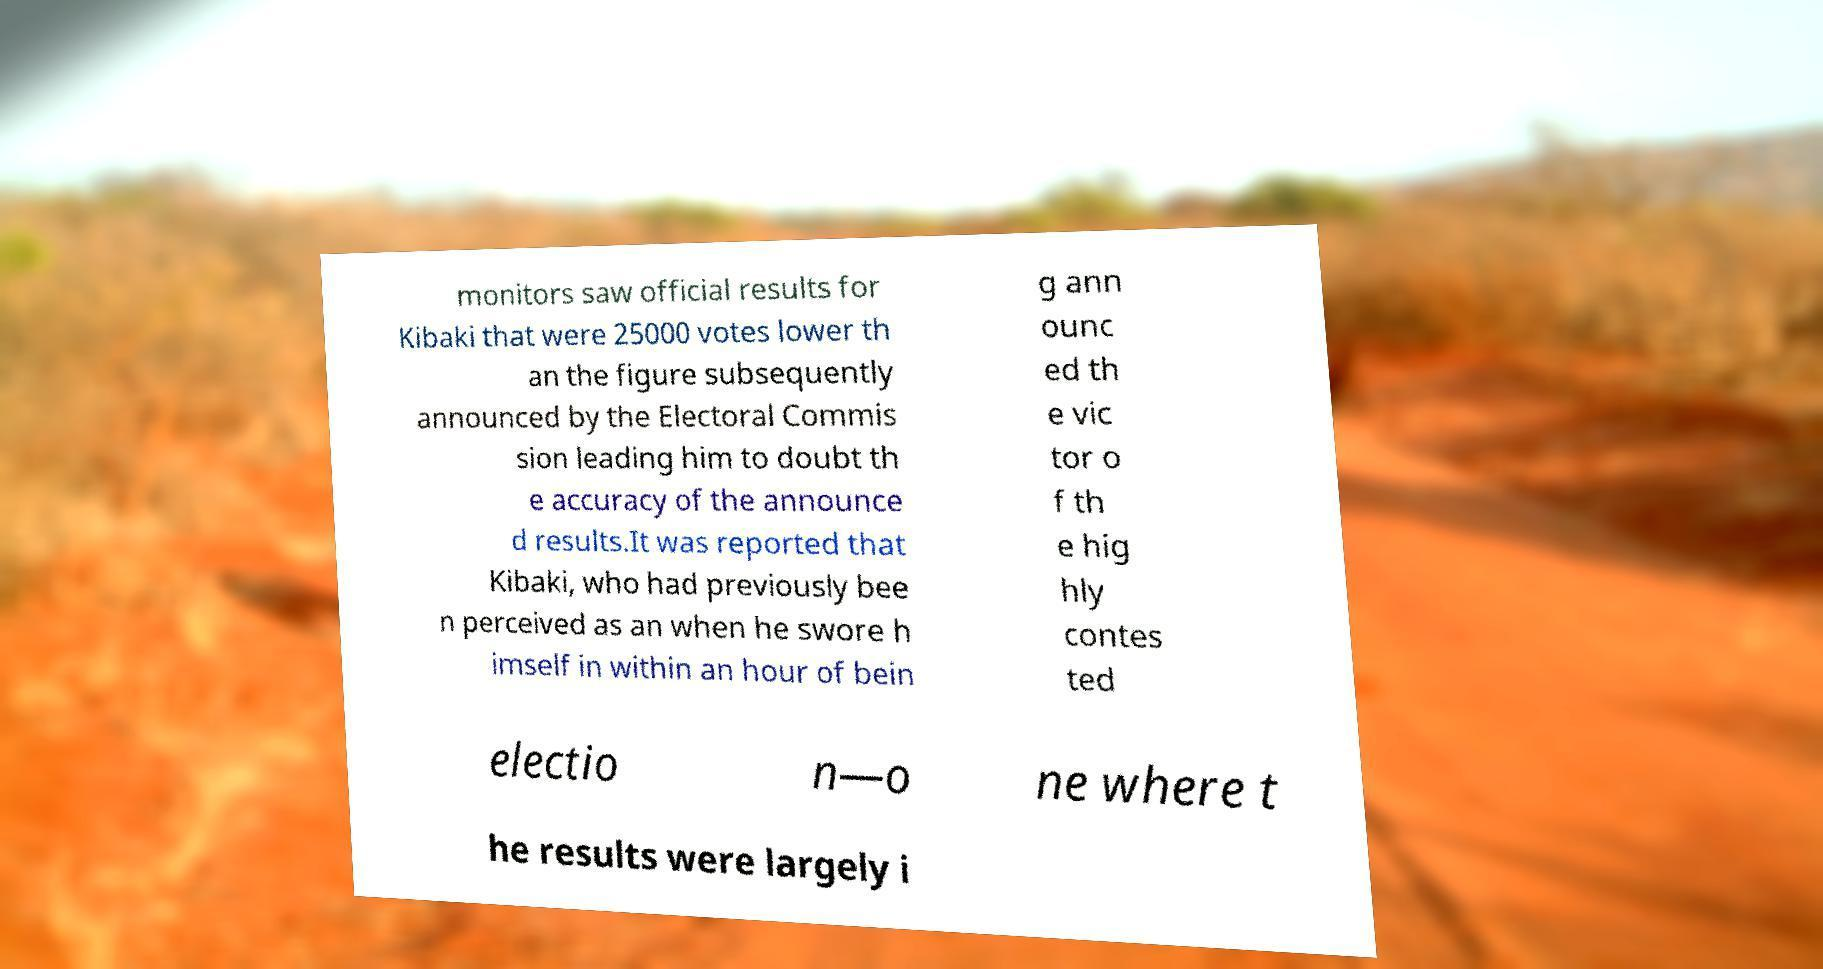What messages or text are displayed in this image? I need them in a readable, typed format. monitors saw official results for Kibaki that were 25000 votes lower th an the figure subsequently announced by the Electoral Commis sion leading him to doubt th e accuracy of the announce d results.It was reported that Kibaki, who had previously bee n perceived as an when he swore h imself in within an hour of bein g ann ounc ed th e vic tor o f th e hig hly contes ted electio n—o ne where t he results were largely i 